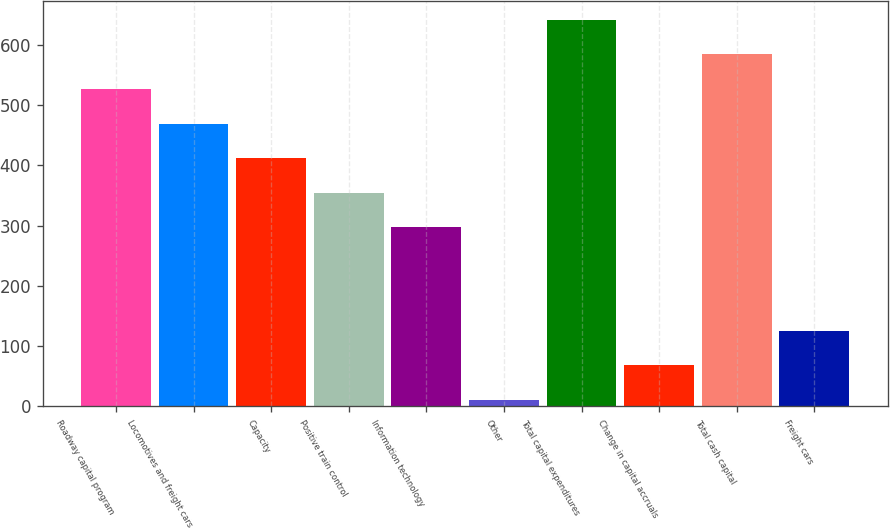Convert chart. <chart><loc_0><loc_0><loc_500><loc_500><bar_chart><fcel>Roadway capital program<fcel>Locomotives and freight cars<fcel>Capacity<fcel>Positive train control<fcel>Information technology<fcel>Other<fcel>Total capital expenditures<fcel>Change in capital accruals<fcel>Total cash capital<fcel>Freight cars<nl><fcel>526.71<fcel>469.42<fcel>412.13<fcel>354.84<fcel>297.55<fcel>11.1<fcel>641.29<fcel>68.39<fcel>584<fcel>125.68<nl></chart> 